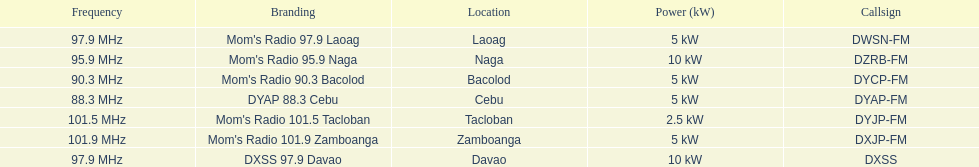What is the total number of stations with frequencies above 100 mhz? 2. Parse the table in full. {'header': ['Frequency', 'Branding', 'Location', 'Power (kW)', 'Callsign'], 'rows': [['97.9\xa0MHz', "Mom's Radio 97.9 Laoag", 'Laoag', '5\xa0kW', 'DWSN-FM'], ['95.9\xa0MHz', "Mom's Radio 95.9 Naga", 'Naga', '10\xa0kW', 'DZRB-FM'], ['90.3\xa0MHz', "Mom's Radio 90.3 Bacolod", 'Bacolod', '5\xa0kW', 'DYCP-FM'], ['88.3\xa0MHz', 'DYAP 88.3 Cebu', 'Cebu', '5\xa0kW', 'DYAP-FM'], ['101.5\xa0MHz', "Mom's Radio 101.5 Tacloban", 'Tacloban', '2.5\xa0kW', 'DYJP-FM'], ['101.9\xa0MHz', "Mom's Radio 101.9 Zamboanga", 'Zamboanga', '5\xa0kW', 'DXJP-FM'], ['97.9\xa0MHz', 'DXSS 97.9 Davao', 'Davao', '10\xa0kW', 'DXSS']]} 